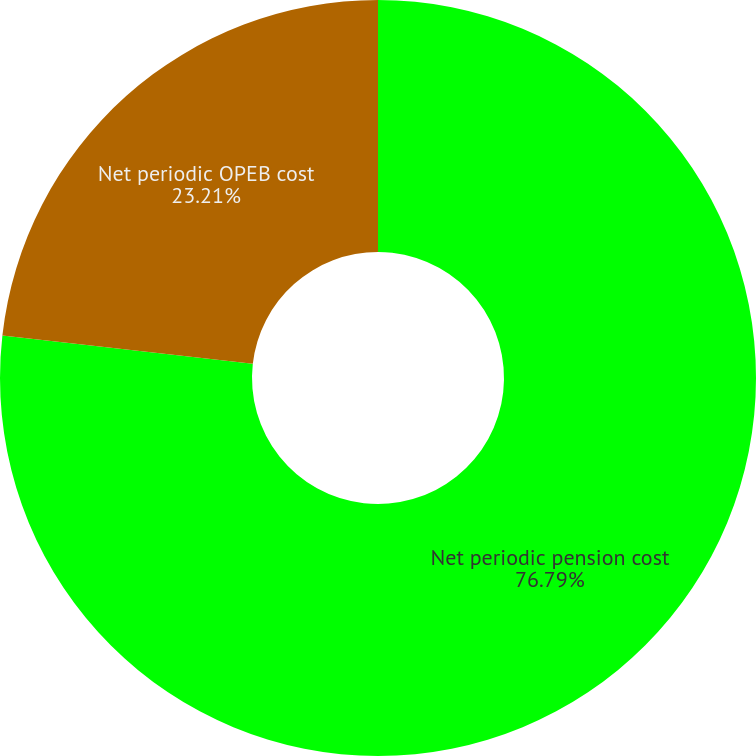Convert chart. <chart><loc_0><loc_0><loc_500><loc_500><pie_chart><fcel>Net periodic pension cost<fcel>Net periodic OPEB cost<nl><fcel>76.79%<fcel>23.21%<nl></chart> 